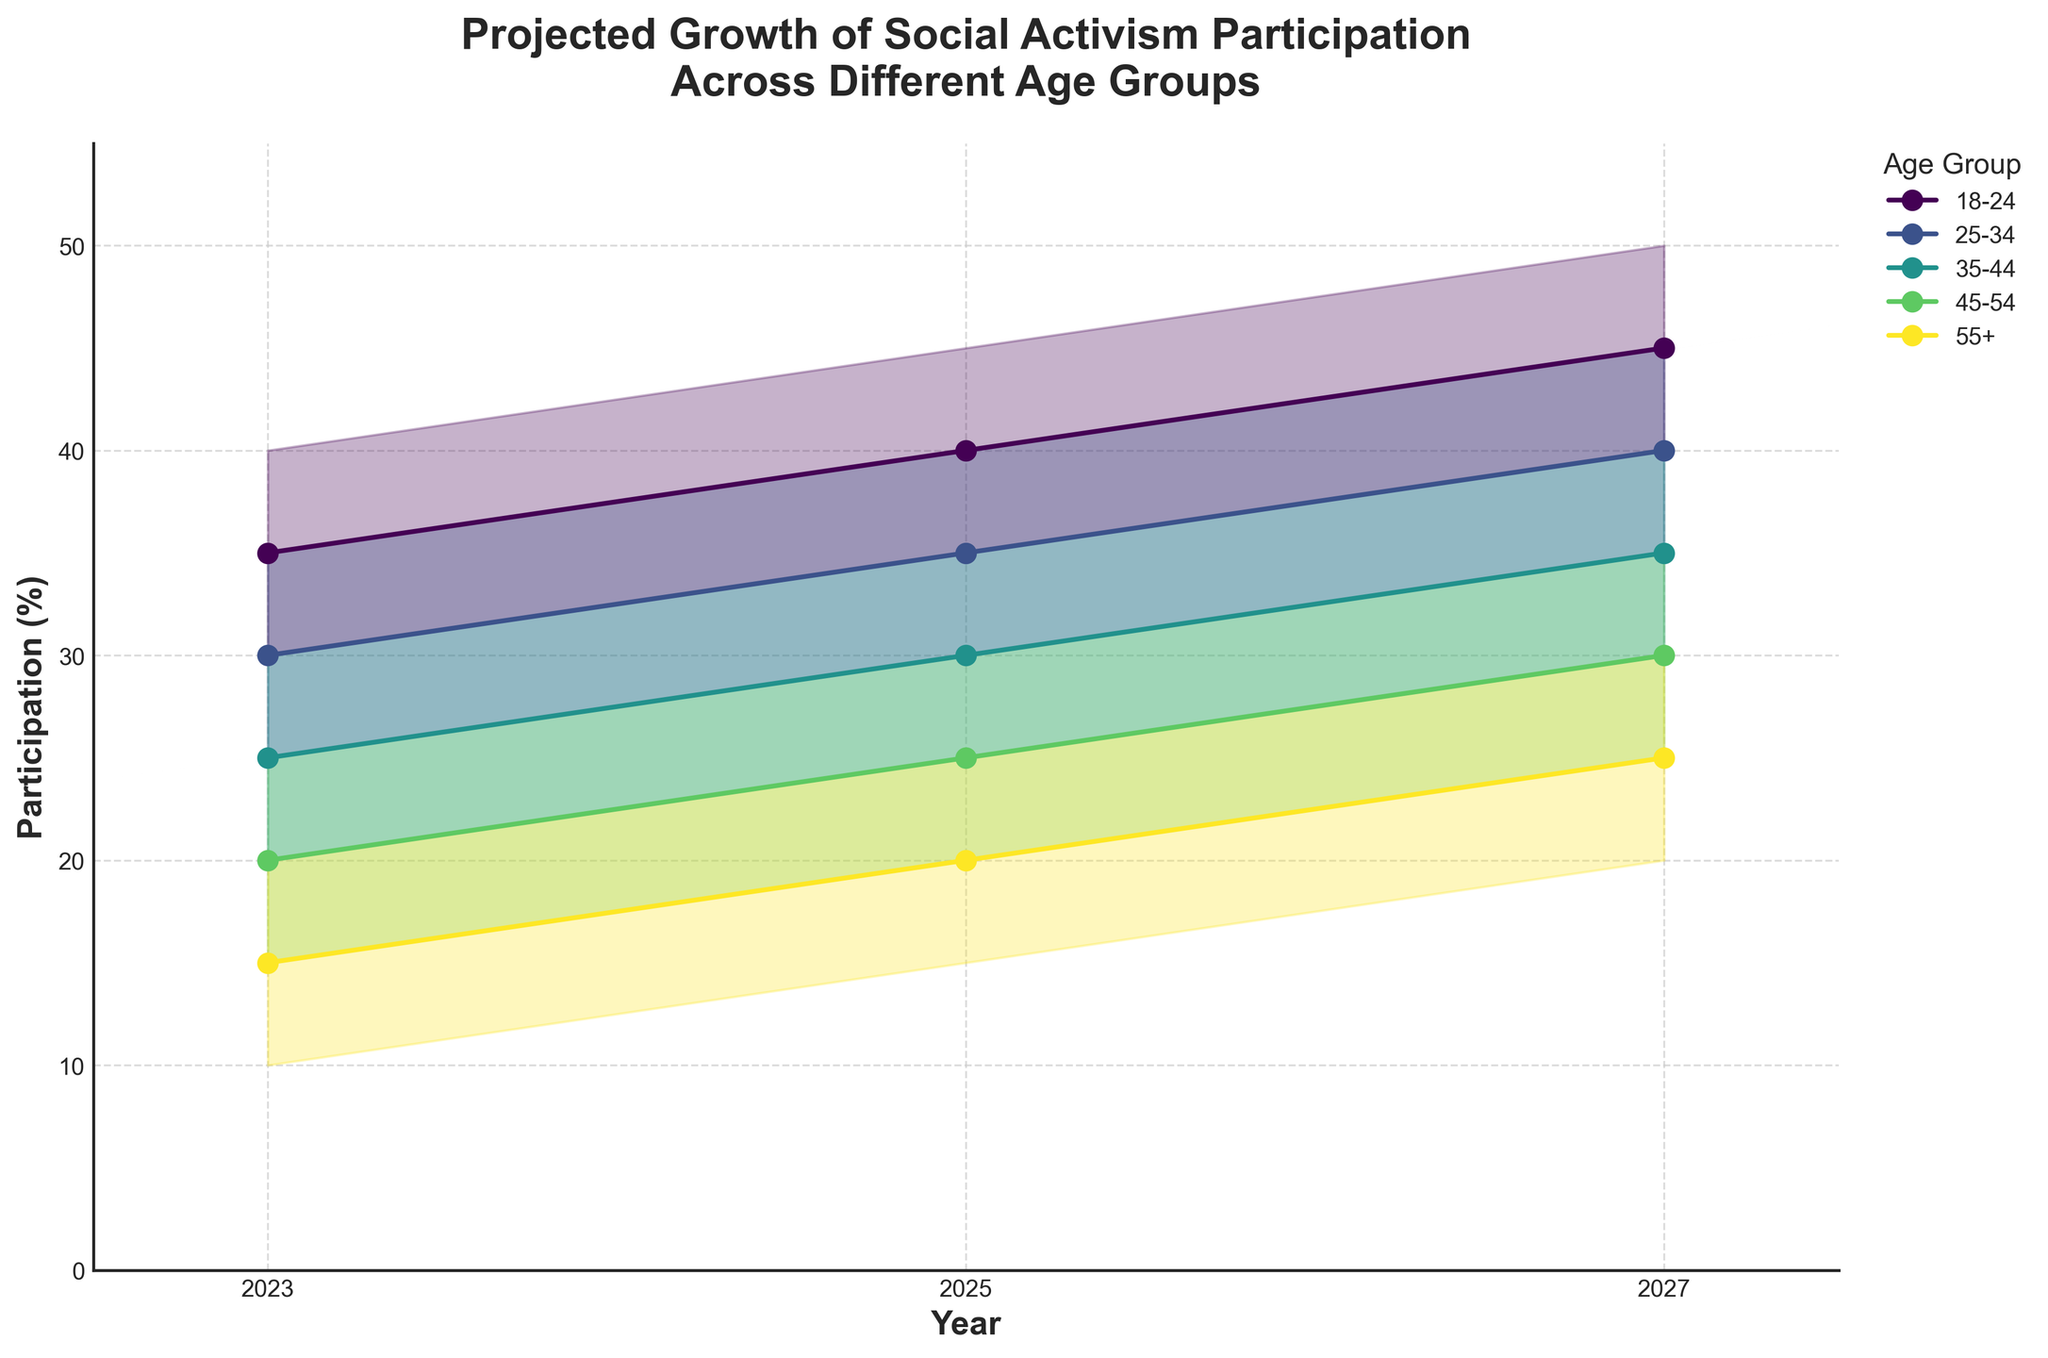What is the title of the chart? The title of the chart is prominently displayed at the top and reads "Projected Growth of Social Activism Participation Across Different Age Groups".
Answer: Projected Growth of Social Activism Participation Across Different Age Groups Which age group is projected to have the highest median participation in 2027? According to the chart, the age group 18-24 is projected to have the highest median participation in 2027, indicated by the highest median line in 2027.
Answer: 18-24 How does the median estimate for the 25-34 age group change from 2023 to 2027? To answer this, we observe the median estimate in 2023 and 2027 for the 25-34 age group, which changes from 30% in 2023 to 40% in 2027. This indicates an increase of 10%.
Answer: Increases by 10% Which age group shows the smallest change in the high estimate from 2023 to 2027? We compare the high estimates for each age group from 2023 to 2027. The 55+ age group has the smallest change from 20% to 30%, a difference of 10%.
Answer: 55+ What is the range of participation (difference between high and low estimates) for the 35-44 age group in 2025? The range is calculated by subtracting the low estimate from the high estimate for the 35-44 age group in 2025, which results in 35% - 25% = 10%.
Answer: 10% Which age group has the highest low estimate in any given year, and what is that estimate? Observing the low estimates across all years, the age group 18-24 has the highest low estimate in 2027 with a value of 40%.
Answer: 18-24, 40% How does the participation of the 45-54 age group compare to the 55+ age group in 2025 based on median estimates? We compare the median estimates for the 45-54 age group (25%) to the 55+ age group (20%) in 2025. The 45-54 age group has a higher median participation.
Answer: 45-54 has higher median participation What is the overall trend in the median participation for all age groups from 2023 to 2027? Evaluating the median estimates for all age groups from 2023 to 2027, there is a noticeable increasing trend in participation for all age groups indicating rising social activism.
Answer: Increasing Which age group's high estimate equals another age group's median estimate in 2025, and what is that value? The high estimate for the 45-54 age group (30%) equals the median estimate for the 35-44 age group (30%) in 2025.
Answer: 45-54 high estimate and 35-44 median estimate, 30% 